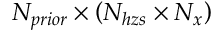Convert formula to latex. <formula><loc_0><loc_0><loc_500><loc_500>N _ { p r i o r } \times \left ( N _ { h z s } \times N _ { x } \right )</formula> 